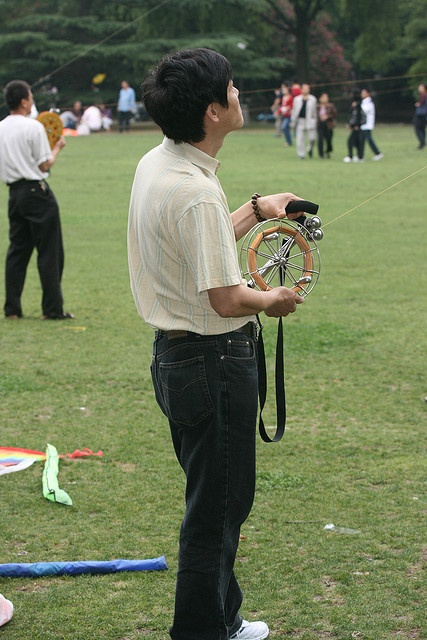Describe the objects in this image and their specific colors. I can see people in darkgreen, black, darkgray, lightgray, and gray tones, people in darkgreen, black, lightgray, darkgray, and gray tones, kite in darkgreen, beige, olive, and khaki tones, people in darkgreen, darkgray, lightgray, and gray tones, and people in darkgreen, lavender, black, gray, and darkgray tones in this image. 